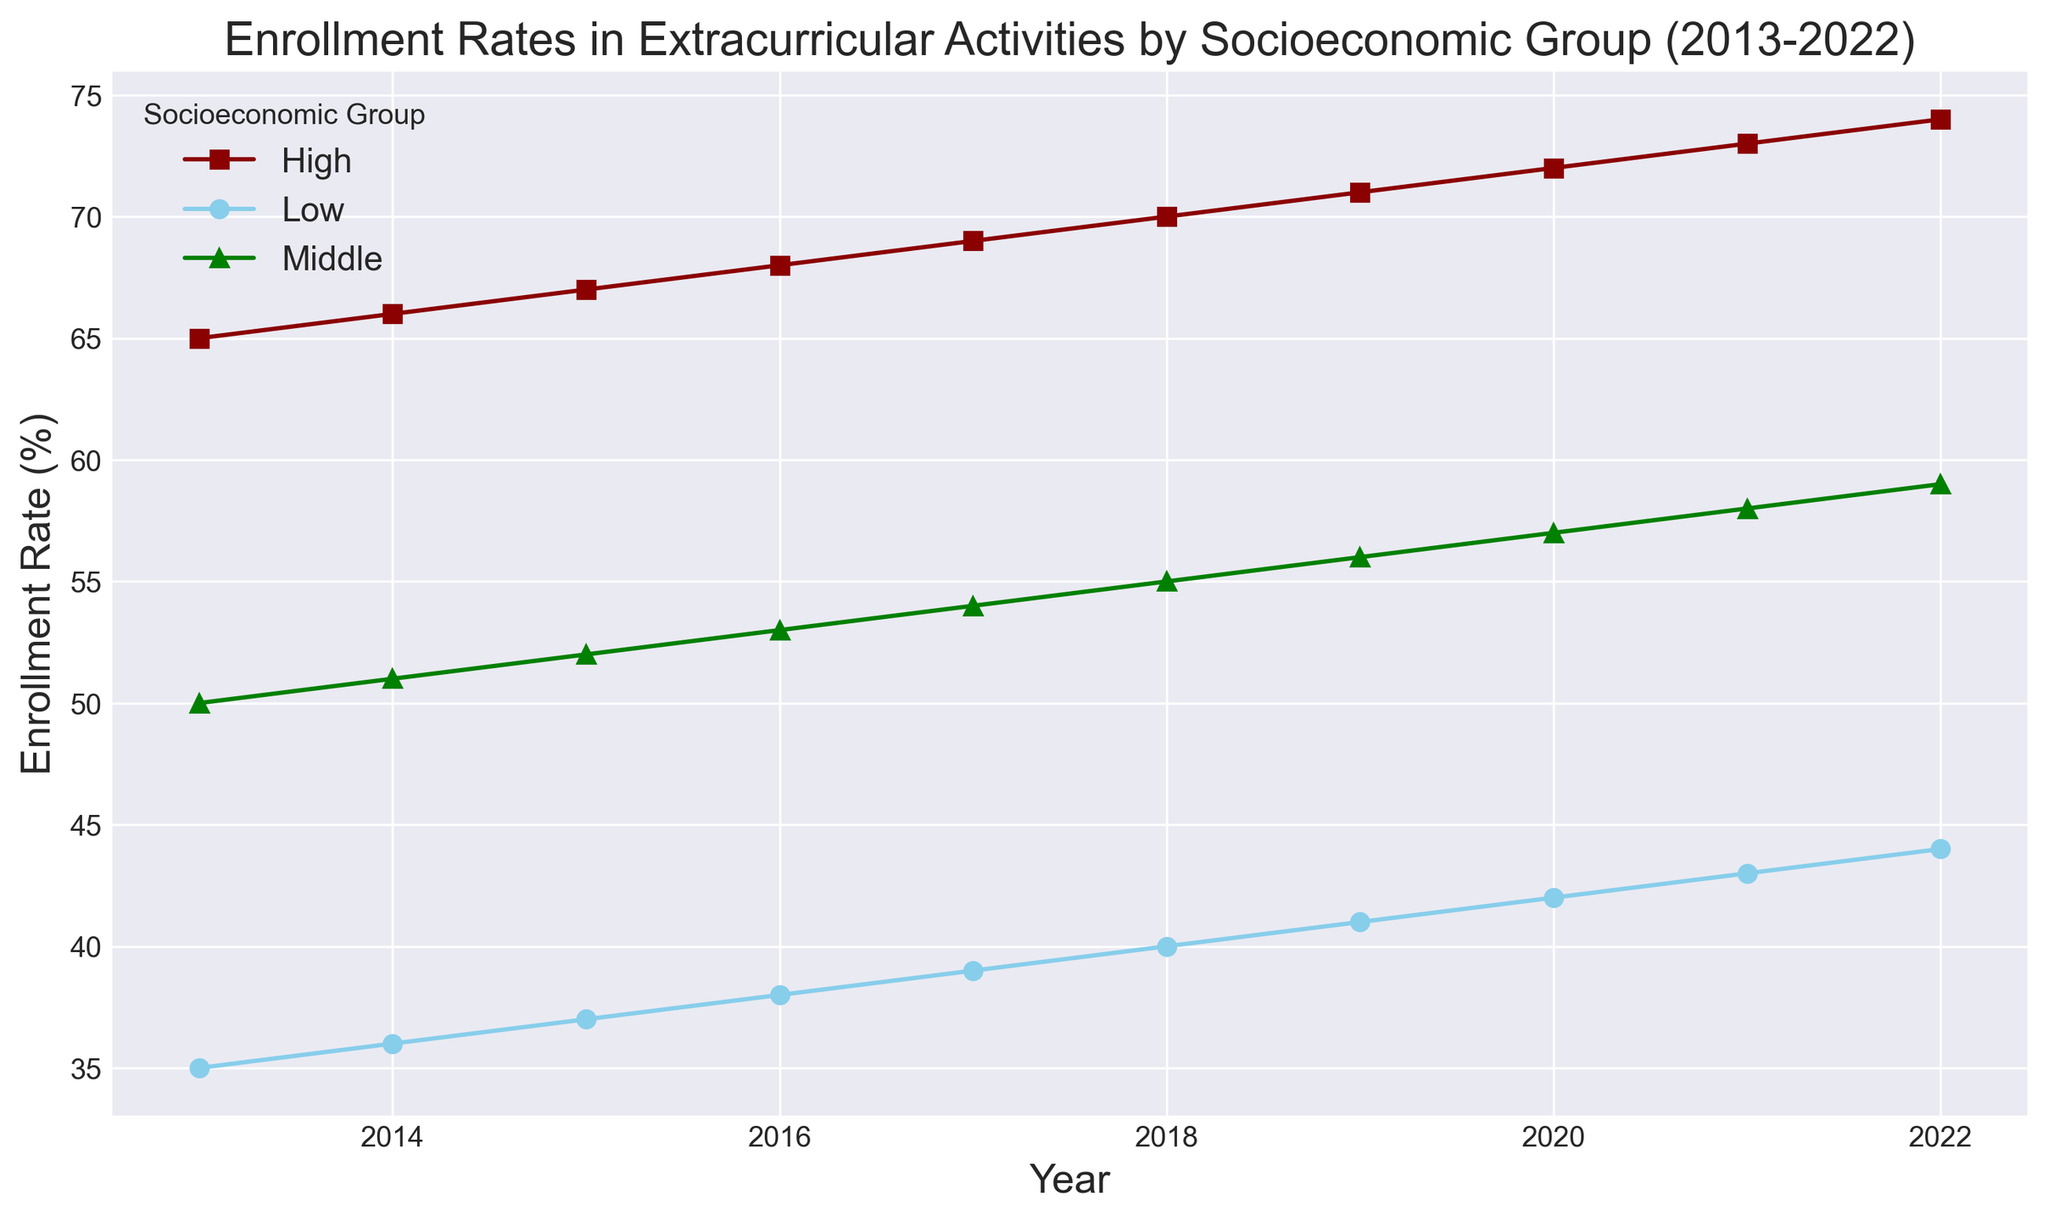Which socioeconomic group had the highest enrollment rate in 2022? In the chart, the 'High' socioeconomic group had the highest enrollment rate in 2022. The legend associates the 'High' group with a specific marker and color, and its line is highest on the y-axis for this year.
Answer: High What is the total increase in enrollment rate for the Low socioeconomic group from 2013 to 2022? The enrollment rate for the Low socioeconomic group in 2013 was 35%, and in 2022 it was 44%. To find the total increase, subtract the 2013 rate from the 2022 rate: 44% - 35% = 9%.
Answer: 9% By how many percentage points did the Middle socioeconomic group's enrollment rate rise from 2015 to 2018? The enrollment rate for the Middle socioeconomic group was 52% in 2015 and 55% in 2018. Subtract the 2015 value from the 2018 value: 55% - 52% = 3%.
Answer: 3% Which socioeconomic group had the smallest increase in enrollment rate between 2013 and 2022? By comparing the start (2013) and end (2022) points for each group: Low increased from 35% to 44% (9%), Middle from 50% to 59% (9%), and High from 65% to 74% (9%). All groups had the same increase. But given the same increase in absolute percentage points, 'Low' began and ended at a lower rate, providing insight into relative differences.
Answer: Low, Middle, High (same rate of increase) What was the average enrollment rate for the High socioeconomic group over the 10-year period shown in the plot? First, add up the annual rates for the High group between 2013 to 2022: 65 + 66 + 67 + 68 + 69 + 70 + 71 + 72 + 73 + 74 = 695. Then divide by the number of years (10): 695 / 10 = 69.5%.
Answer: 69.5% When did the Low socioeconomic group reach an enrollment rate of at least 40% for the first time? Looking at the trend line for the Low socioeconomic group, it reached 40% in the year 2018. This can be identified by looking for the first year the line crosses the 40% mark on the y-axis.
Answer: 2018 Compare the trend in enrollment rates for Low and Middle socioeconomic groups. Which group had a more consistent rate of increase over the years? Both groups show an upward trend, but the Middle group's line appears to rise more steadily and consistently without significant fluctuations compared to the Low group.
Answer: Middle In which year was the enrollment rate for the High socioeconomic group exactly 71%? Observing the plot, the High group's line reaches 71% in the year 2019.
Answer: 2019 During which year did all three socioeconomic groups have the same rate of increase compared to the previous year? To identify equal increases, you can compare year-on-year growth visually. In 2015, all groups show a similar incremental rise in their lines compared to 2014, but overall yearly increments are approximately parallel without notable differing slopes.
Answer: 2015 What is the difference in enrollment rates between the High and Low socioeconomic groups in 2020? The enrollment rate for the High group in 2020 is 72%, and for the Low group, it is 42%. Subtract the Low rate from the High rate: 72% - 42% = 30%.
Answer: 30% 